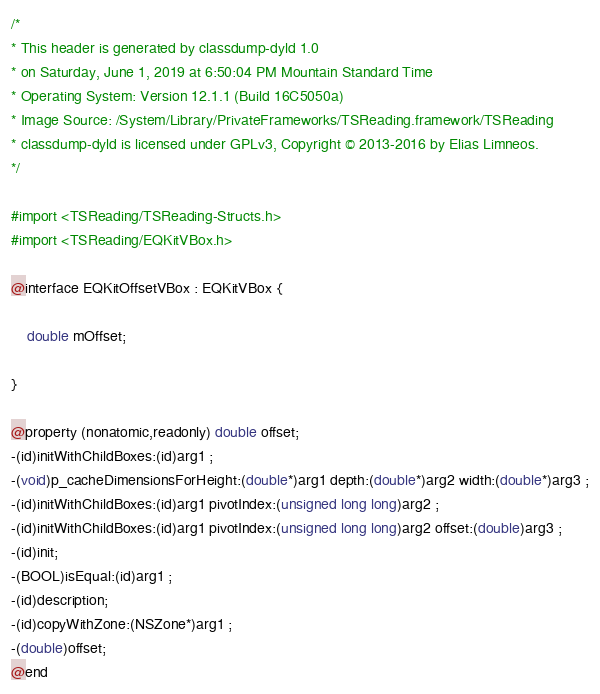<code> <loc_0><loc_0><loc_500><loc_500><_C_>/*
* This header is generated by classdump-dyld 1.0
* on Saturday, June 1, 2019 at 6:50:04 PM Mountain Standard Time
* Operating System: Version 12.1.1 (Build 16C5050a)
* Image Source: /System/Library/PrivateFrameworks/TSReading.framework/TSReading
* classdump-dyld is licensed under GPLv3, Copyright © 2013-2016 by Elias Limneos.
*/

#import <TSReading/TSReading-Structs.h>
#import <TSReading/EQKitVBox.h>

@interface EQKitOffsetVBox : EQKitVBox {

	double mOffset;

}

@property (nonatomic,readonly) double offset; 
-(id)initWithChildBoxes:(id)arg1 ;
-(void)p_cacheDimensionsForHeight:(double*)arg1 depth:(double*)arg2 width:(double*)arg3 ;
-(id)initWithChildBoxes:(id)arg1 pivotIndex:(unsigned long long)arg2 ;
-(id)initWithChildBoxes:(id)arg1 pivotIndex:(unsigned long long)arg2 offset:(double)arg3 ;
-(id)init;
-(BOOL)isEqual:(id)arg1 ;
-(id)description;
-(id)copyWithZone:(NSZone*)arg1 ;
-(double)offset;
@end

</code> 